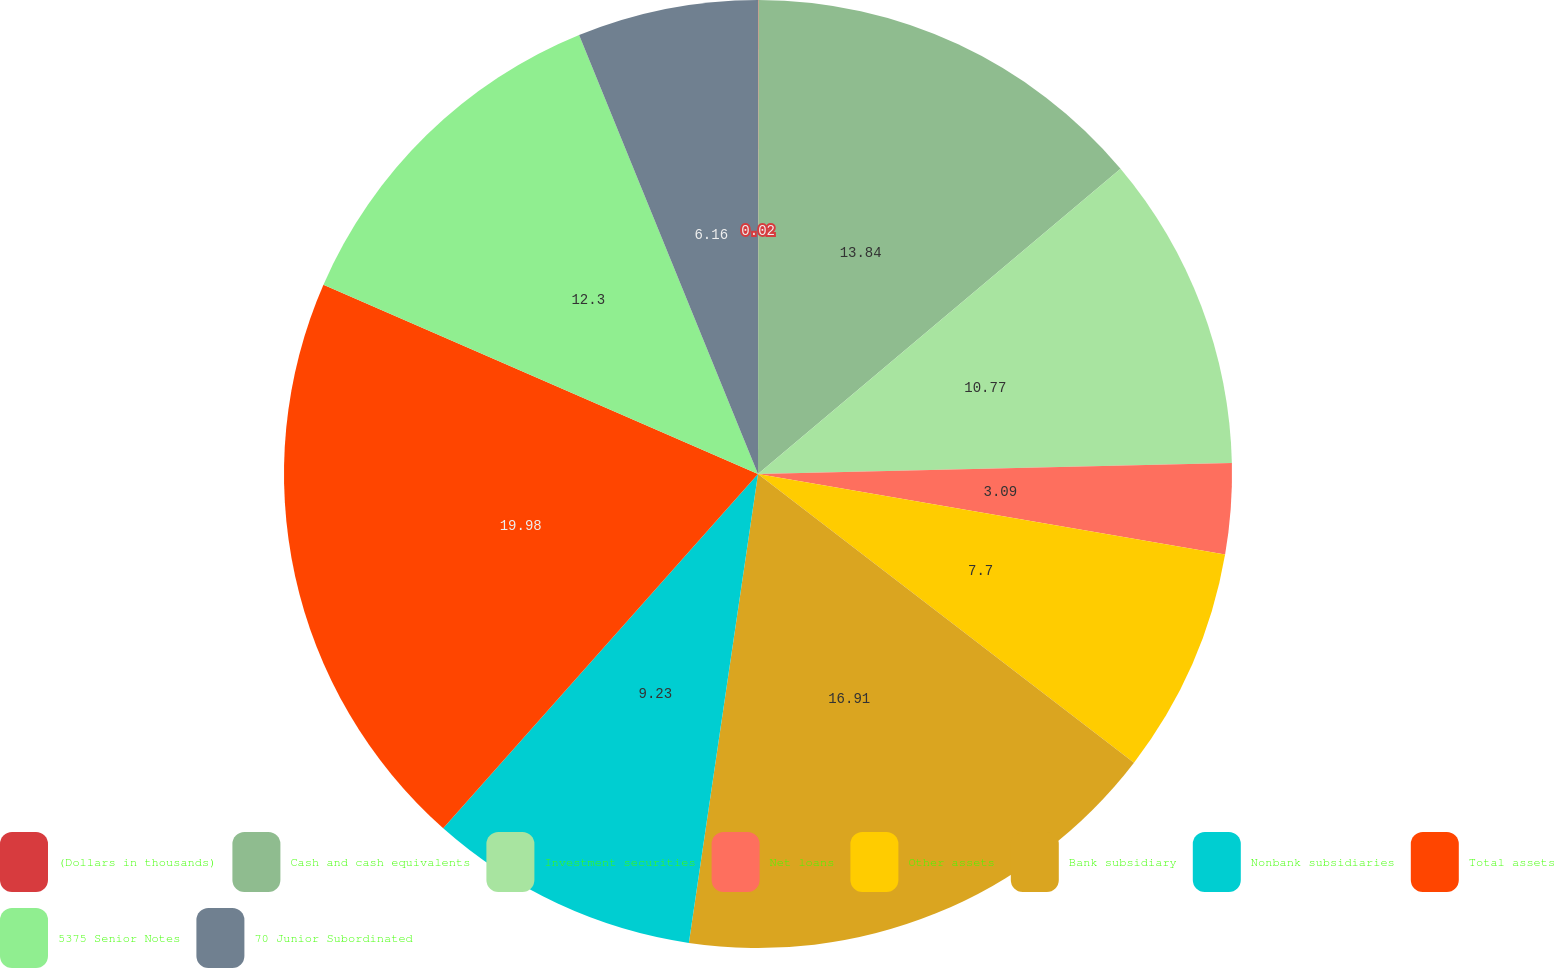Convert chart to OTSL. <chart><loc_0><loc_0><loc_500><loc_500><pie_chart><fcel>(Dollars in thousands)<fcel>Cash and cash equivalents<fcel>Investment securities<fcel>Net loans<fcel>Other assets<fcel>Bank subsidiary<fcel>Nonbank subsidiaries<fcel>Total assets<fcel>5375 Senior Notes<fcel>70 Junior Subordinated<nl><fcel>0.02%<fcel>13.84%<fcel>10.77%<fcel>3.09%<fcel>7.7%<fcel>16.91%<fcel>9.23%<fcel>19.98%<fcel>12.3%<fcel>6.16%<nl></chart> 